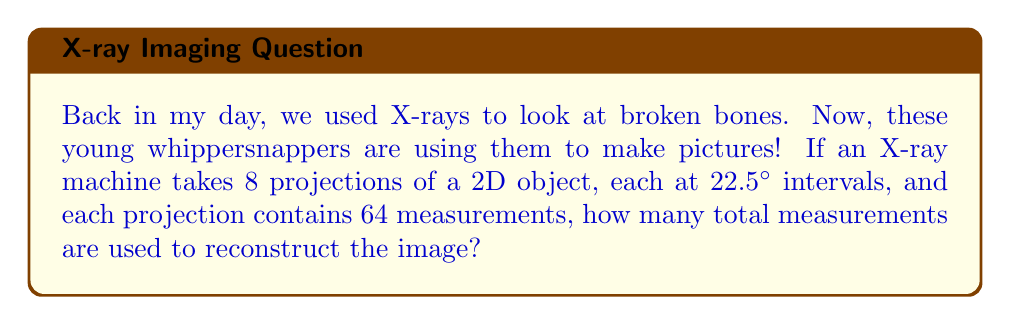Can you answer this question? Let's break this down step-by-step:

1) First, we need to understand what the question is asking. We're looking for the total number of measurements used to reconstruct the image.

2) We're given two important pieces of information:
   - There are 8 projections
   - Each projection contains 64 measurements

3) To find the total number of measurements, we need to multiply the number of projections by the number of measurements per projection:

   $$\text{Total measurements} = \text{Number of projections} \times \text{Measurements per projection}$$

4) Plugging in the numbers:

   $$\text{Total measurements} = 8 \times 64$$

5) Performing the multiplication:

   $$\text{Total measurements} = 512$$

Therefore, 512 total measurements are used to reconstruct the image.

Note: The information about the 22.5° intervals between projections is not directly used in this calculation, but it provides context for how the projections were taken around the object.
Answer: 512 measurements 